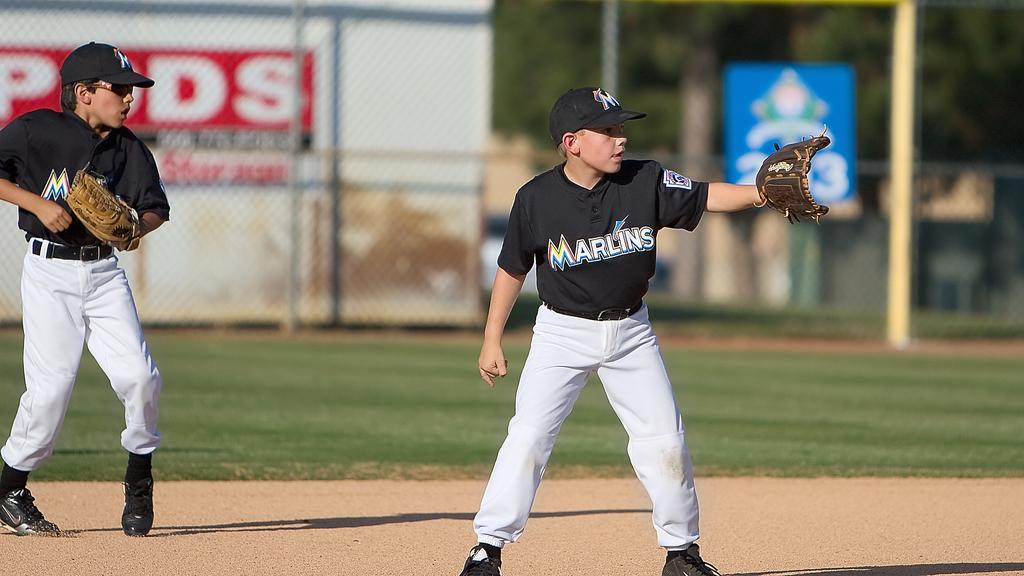<image>
Summarize the visual content of the image. A player for the Marlins holds out his glove to catch a baseball. 